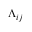<formula> <loc_0><loc_0><loc_500><loc_500>\Lambda _ { i j }</formula> 